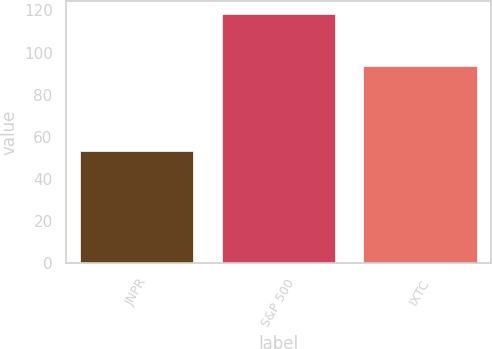<chart> <loc_0><loc_0><loc_500><loc_500><bar_chart><fcel>JNPR<fcel>S&P 500<fcel>IXTC<nl><fcel>53.28<fcel>118.44<fcel>93.69<nl></chart> 